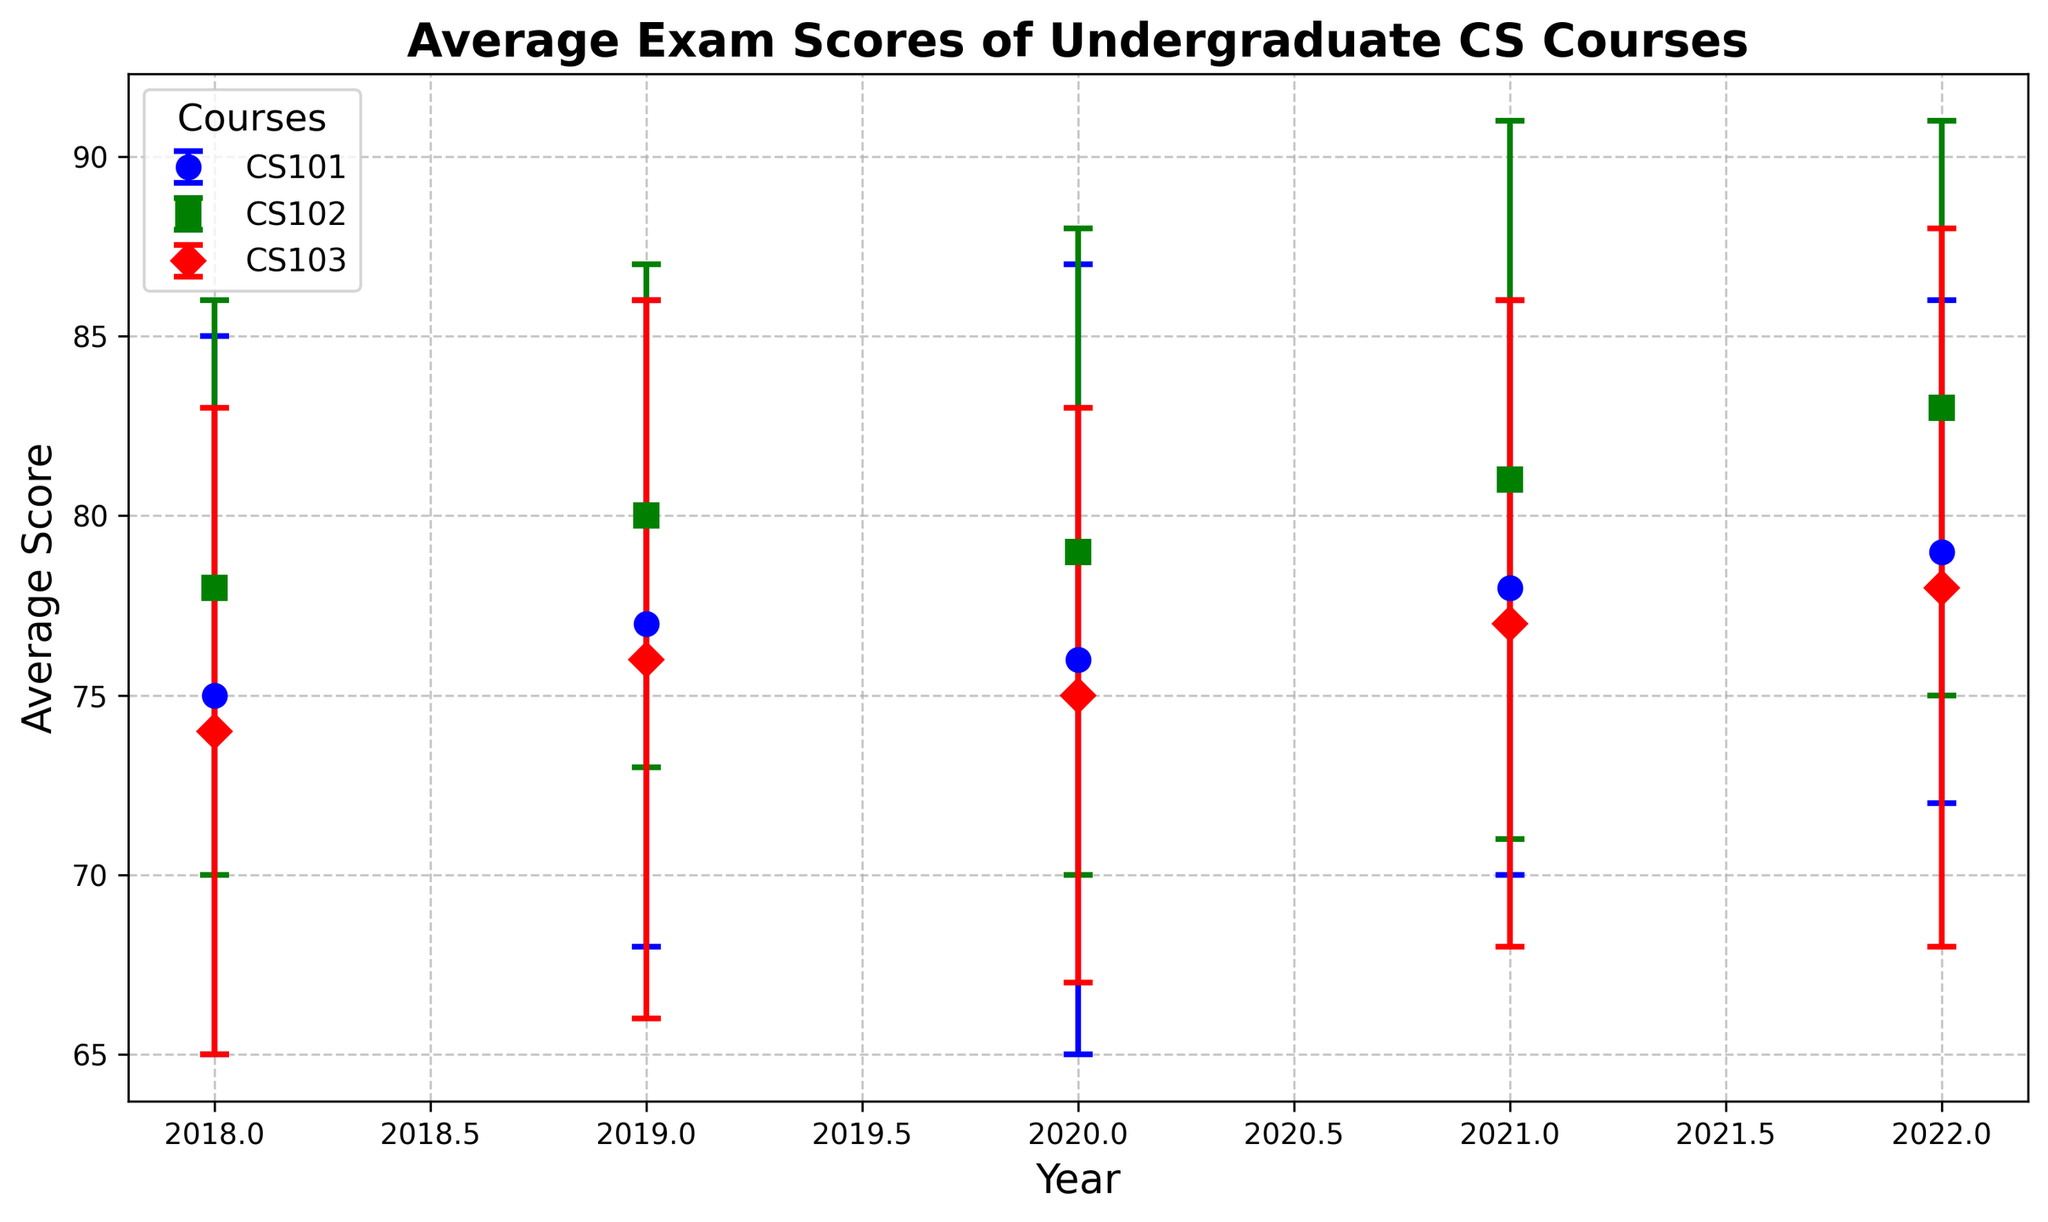What is the general trend of average exam scores for CS101 from 2018 to 2022? From the plot, you can see the year-over-year variation in the average scores for CS101. The scores show a general increasing trend from 75 in 2018 to 79 in 2022 with minor fluctuations.
Answer: Increasing trend Compare the average exam scores of CS102 in 2018 and 2022. In the plot, locate the positions of the CS102 markers for 2018 and 2022. In 2018, the average score for CS102 is 78, and in 2022, it is 83.
Answer: 78 vs 83 Which course had the highest average exam score in 2021? Identify the position of the highest marker in each year from the figure. For 2021, CS102 has the highest average score of 81.
Answer: CS102 In which year did CS103 have the lowest average exam score, and what was its value? Observe the error bars for CS103 across the years and identify the lowest point. In 2018, CS103 had the lowest average score of 74.
Answer: 2018, 74 What can you infer from the standard deviations of CS101 in 2020 and 2022? Compare the lengths of the error bars for CS101 in different years. The standard deviation for CS101 in 2020 is larger (11) than in 2022 (7), indicating more variability in exam scores in 2020.
Answer: More variability in 2020 How does the average exam score of CS103 in 2019 compare to that of CS101 in the same year? Look at the markers for both courses in 2019. The average exam score was 76 for CS103 and 77 for CS101.
Answer: CS103: 76, CS101: 77 Which course showed the least year-over-year variability in average exam scores from 2018 to 2022? Compare the error bars of each course. CS102 consistently shows smaller error bars over the years, indicating less variability.
Answer: CS102 By how many points did the average exam score of CS101 increase from 2018 to 2022? Find the difference between the average scores of CS101 in 2022 and 2018. 79 - 75 = 4 points.
Answer: 4 points For which year did CS102 have the smallest standard deviation in average exam scores? Identify the shortest error bar for CS102 across all the years. In 2019, the standard deviation is the smallest (7).
Answer: 2019 What can you say about the consistency of exam scores of CS103 based on the error bars? Compare the length of the error bars of CS103 across the years. The standard deviations are relatively stable without drastic changes, indicating consistent performance.
Answer: Consistent performance 